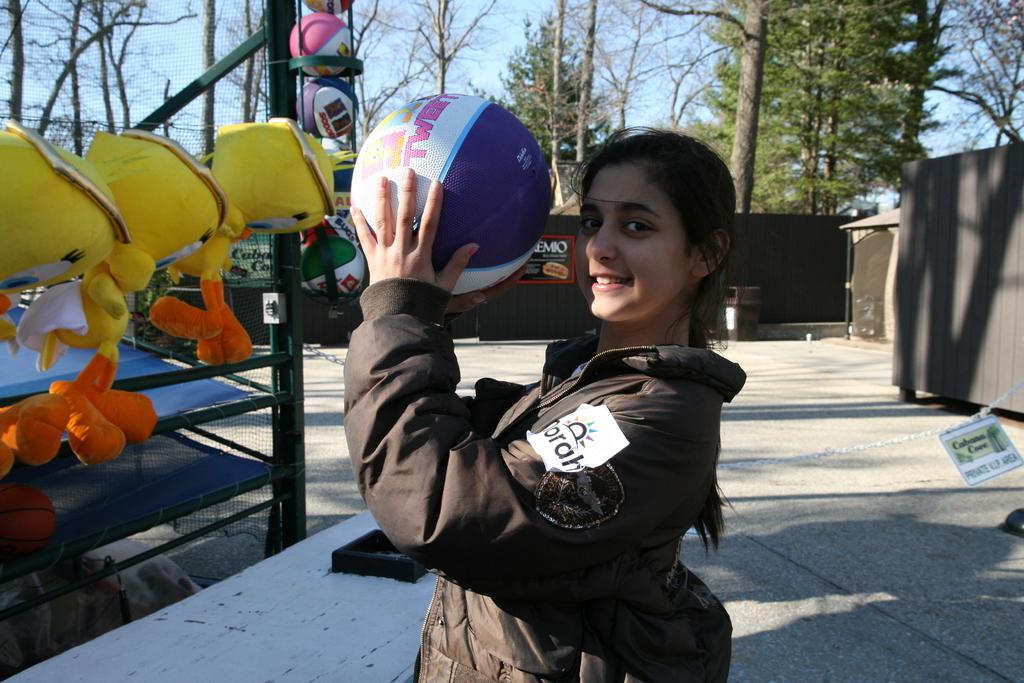Who is the main subject in the image? There is a girl standing in the center of the image. What is the girl holding in her hand? The girl is holding a ball in her hand. What can be seen on the left side of the image? There are soft toys on the left side of the image. What is visible in the background of the image? There are trees and the sky visible in the background of the image. What grade is the girl in, as indicated by the sign in the image? There is no sign in the image indicating the girl's grade. Where is the lunchroom located in the image? There is no lunchroom present in the image. 